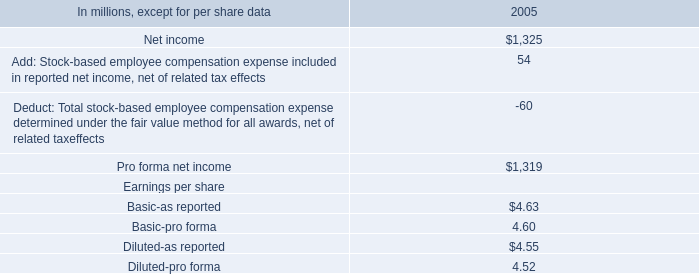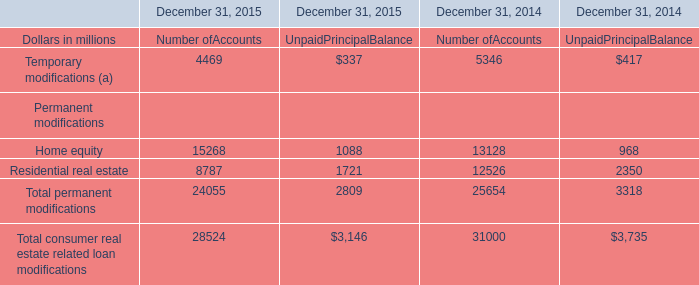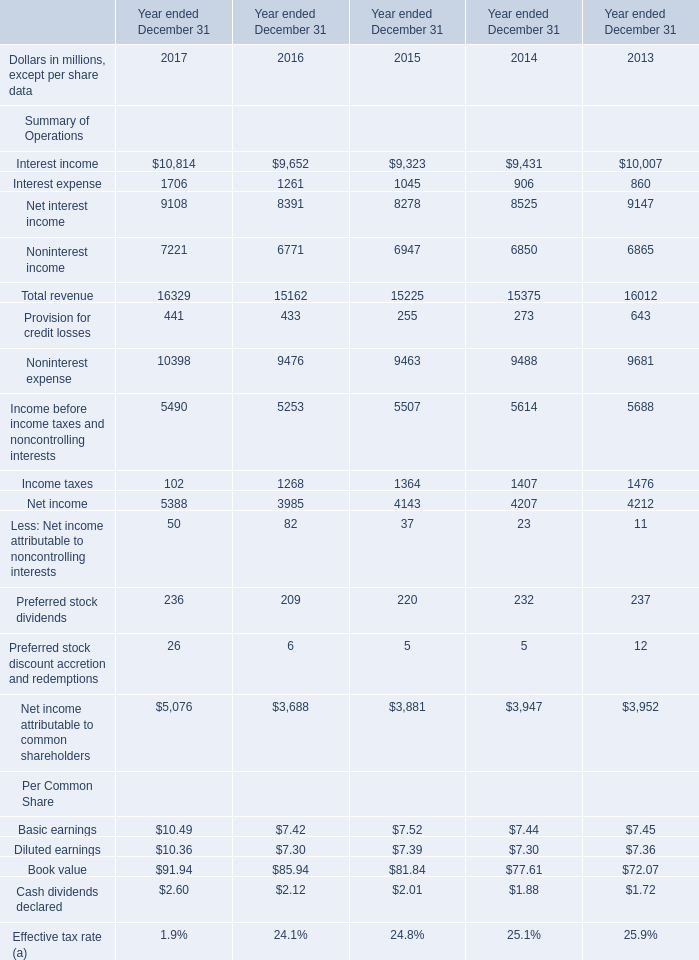What is the growing rate of Total revenue in the years with the least Interest income? 
Computations: ((15162 - 15225) / 15225)
Answer: -0.00414. 